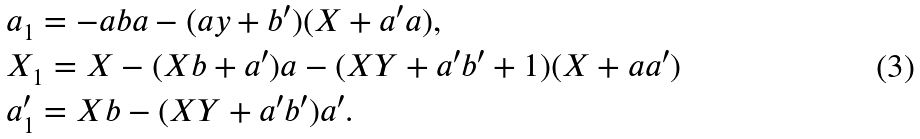<formula> <loc_0><loc_0><loc_500><loc_500>& a _ { 1 } = - a b a - ( a y + b ^ { \prime } ) ( X + a ^ { \prime } a ) , \\ & X _ { 1 } = X - ( X b + a ^ { \prime } ) a - ( X Y + a ^ { \prime } b ^ { \prime } + 1 ) ( X + a a ^ { \prime } ) \\ & a _ { 1 } ^ { \prime } = X b - ( X Y + a ^ { \prime } b ^ { \prime } ) a ^ { \prime } .</formula> 